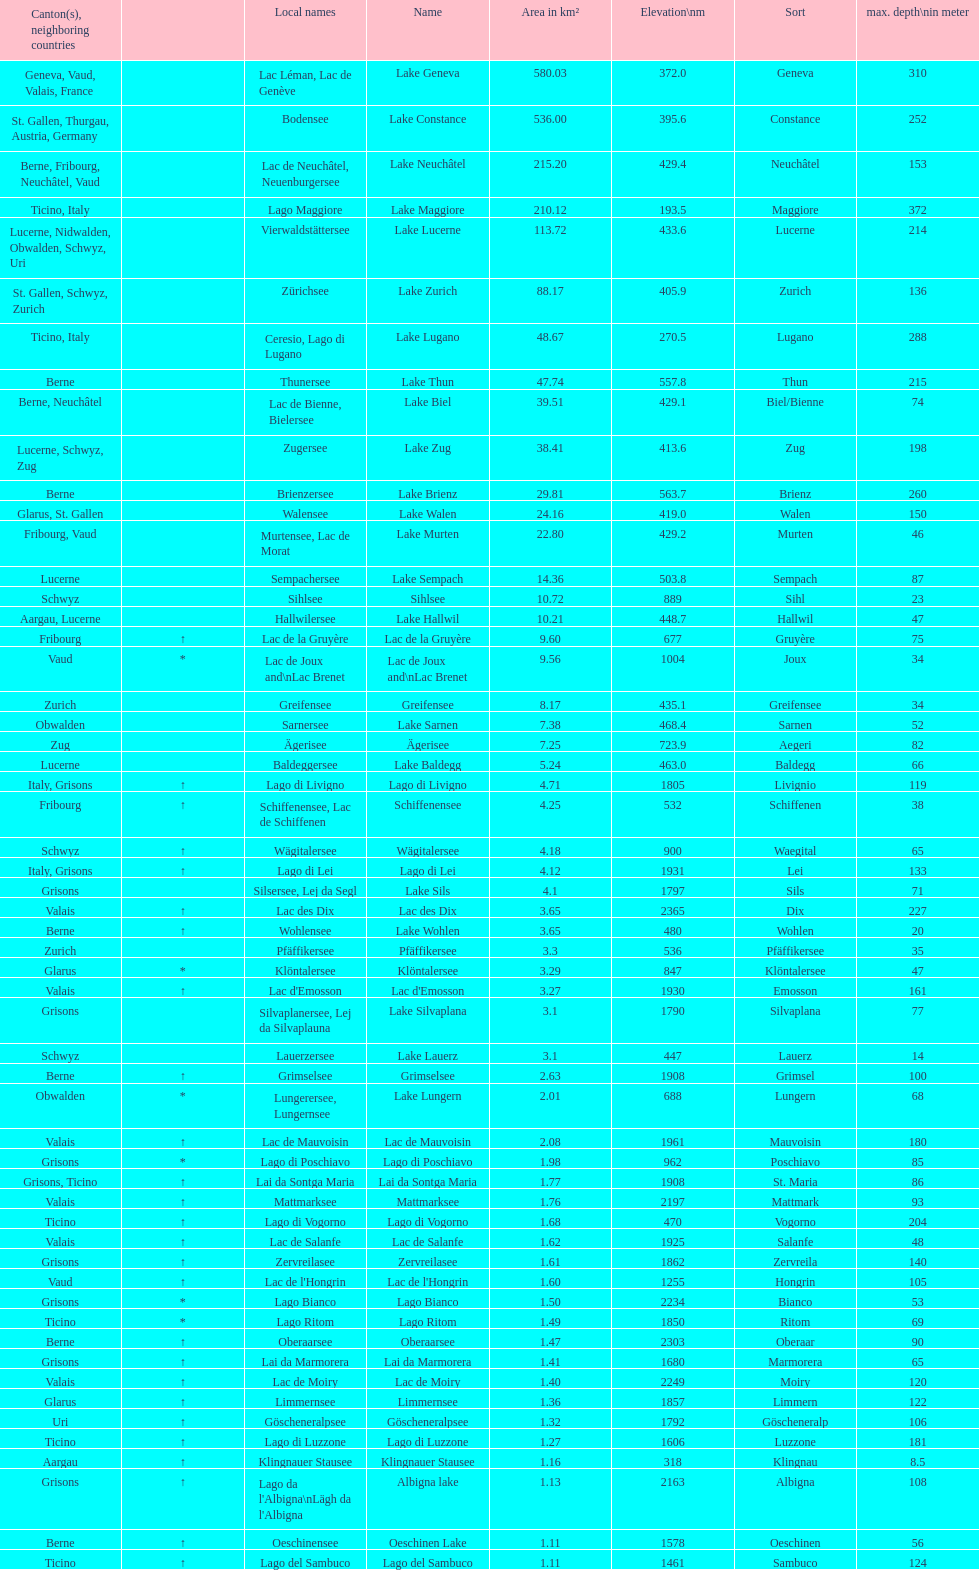Which lake has at least 580 area in km²? Lake Geneva. 